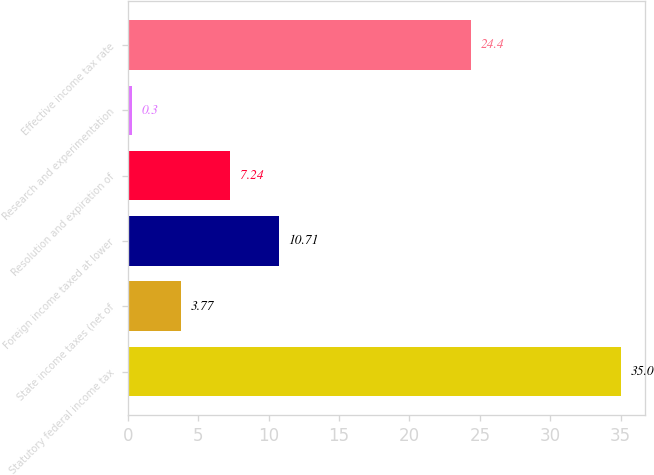Convert chart. <chart><loc_0><loc_0><loc_500><loc_500><bar_chart><fcel>Statutory federal income tax<fcel>State income taxes (net of<fcel>Foreign income taxed at lower<fcel>Resolution and expiration of<fcel>Research and experimentation<fcel>Effective income tax rate<nl><fcel>35<fcel>3.77<fcel>10.71<fcel>7.24<fcel>0.3<fcel>24.4<nl></chart> 